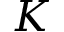<formula> <loc_0><loc_0><loc_500><loc_500>K</formula> 